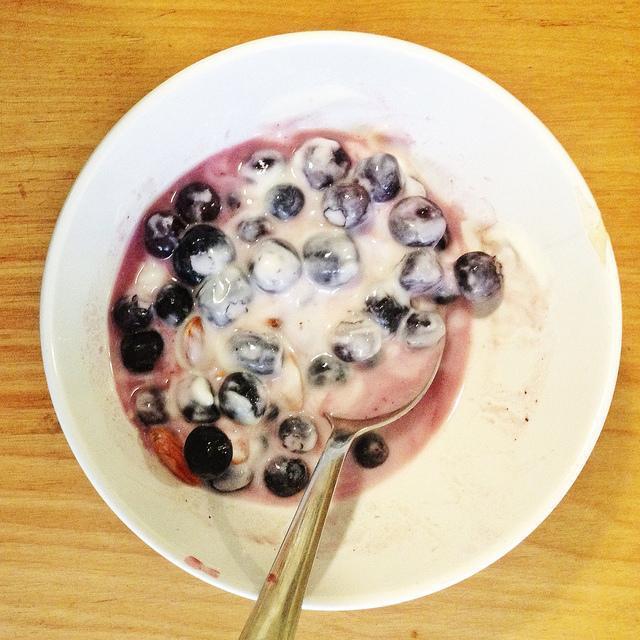How many dining tables are there?
Give a very brief answer. 1. 